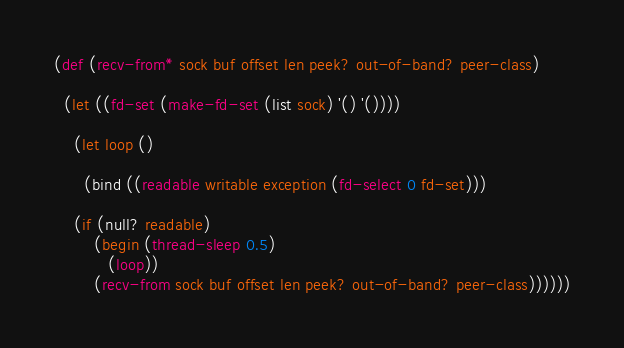Convert code to text. <code><loc_0><loc_0><loc_500><loc_500><_Scheme_>
(def (recv-from* sock buf offset len peek? out-of-band? peer-class)

  (let ((fd-set (make-fd-set (list sock) '() '())))

    (let loop ()

      (bind ((readable writable exception (fd-select 0 fd-set)))

	(if (null? readable)
	    (begin (thread-sleep 0.5)
		   (loop))
	    (recv-from sock buf offset len peek? out-of-band? peer-class))))))</code> 